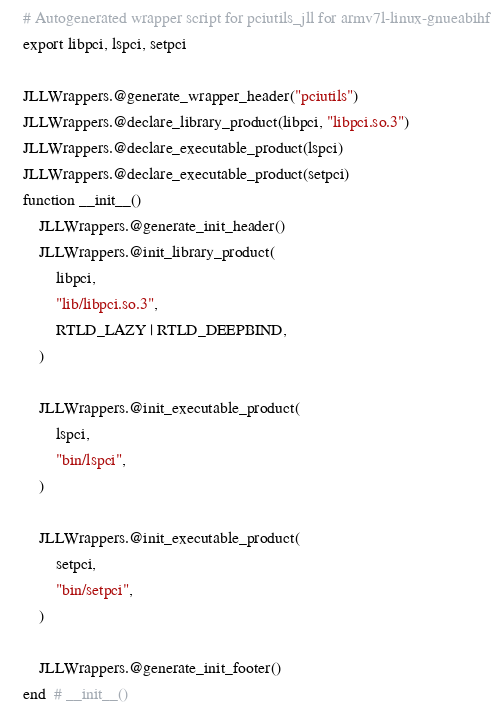Convert code to text. <code><loc_0><loc_0><loc_500><loc_500><_Julia_># Autogenerated wrapper script for pciutils_jll for armv7l-linux-gnueabihf
export libpci, lspci, setpci

JLLWrappers.@generate_wrapper_header("pciutils")
JLLWrappers.@declare_library_product(libpci, "libpci.so.3")
JLLWrappers.@declare_executable_product(lspci)
JLLWrappers.@declare_executable_product(setpci)
function __init__()
    JLLWrappers.@generate_init_header()
    JLLWrappers.@init_library_product(
        libpci,
        "lib/libpci.so.3",
        RTLD_LAZY | RTLD_DEEPBIND,
    )

    JLLWrappers.@init_executable_product(
        lspci,
        "bin/lspci",
    )

    JLLWrappers.@init_executable_product(
        setpci,
        "bin/setpci",
    )

    JLLWrappers.@generate_init_footer()
end  # __init__()
</code> 